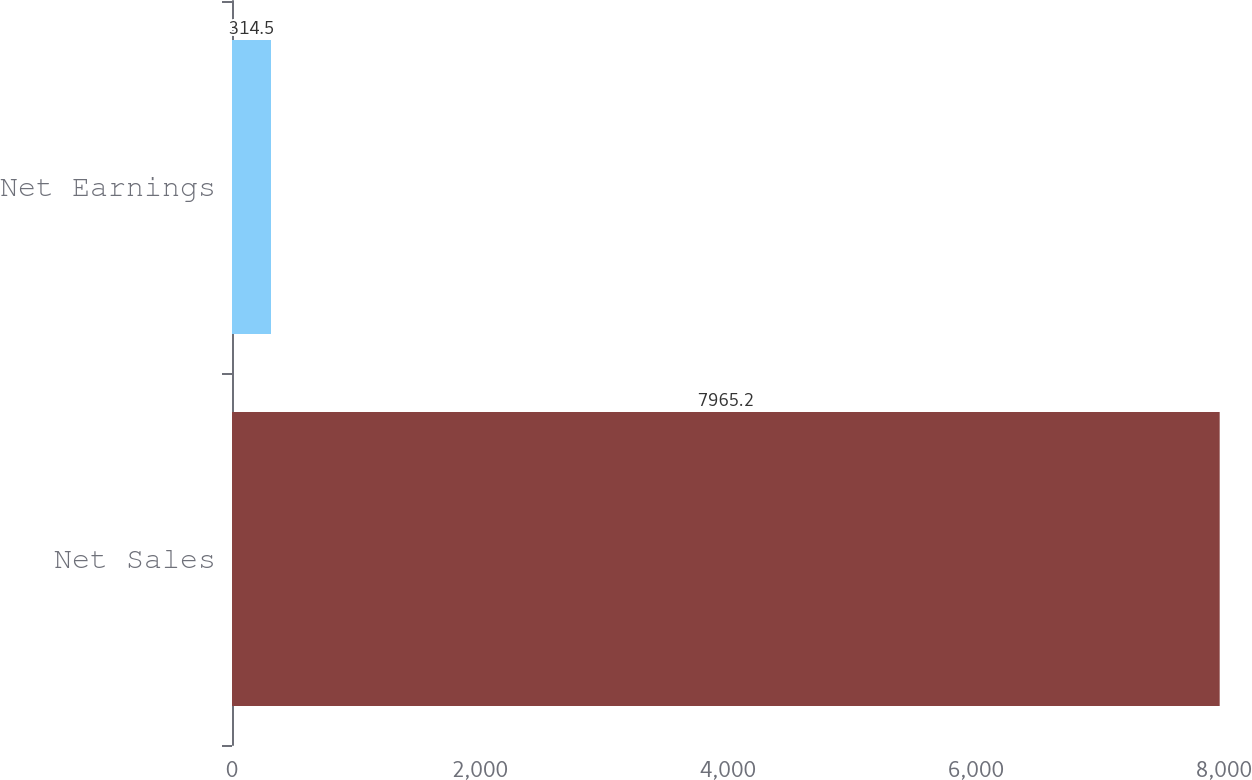Convert chart to OTSL. <chart><loc_0><loc_0><loc_500><loc_500><bar_chart><fcel>Net Sales<fcel>Net Earnings<nl><fcel>7965.2<fcel>314.5<nl></chart> 